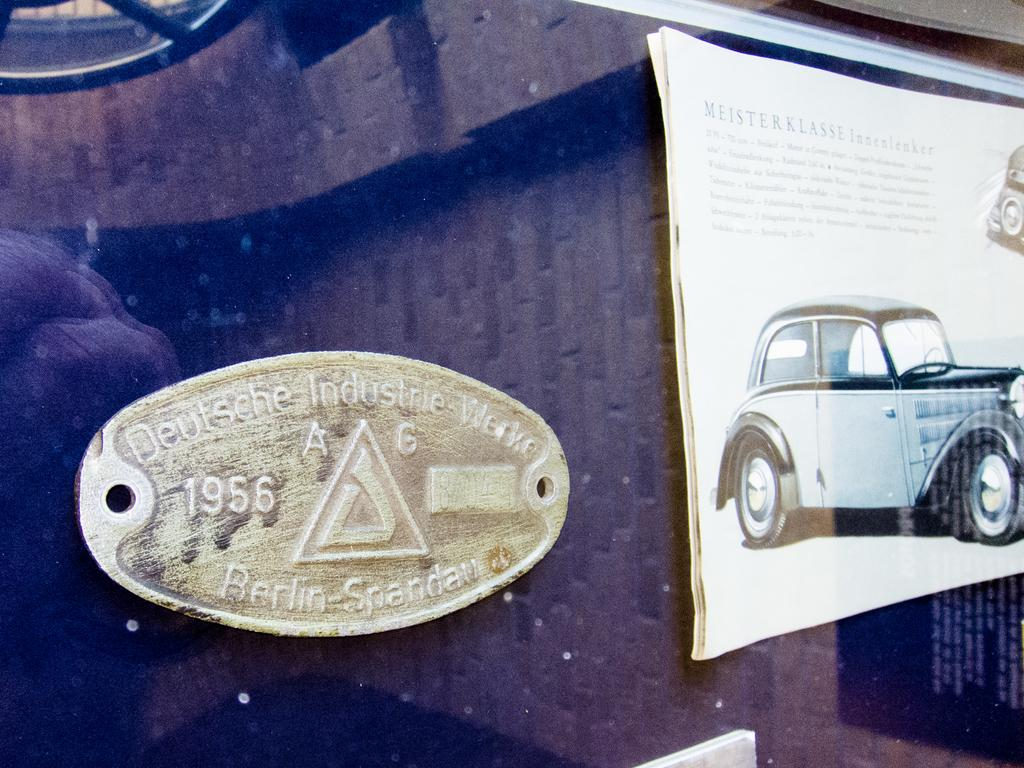What is the main object in the image? There is a vehicle in the image. What else can be seen in the image besides the vehicle? There is a board and a brochure in the image. What type of brick is being used to fight in the image? There is no brick or fighting present in the image. What type of stove can be seen in the image? There is no stove present in the image. 